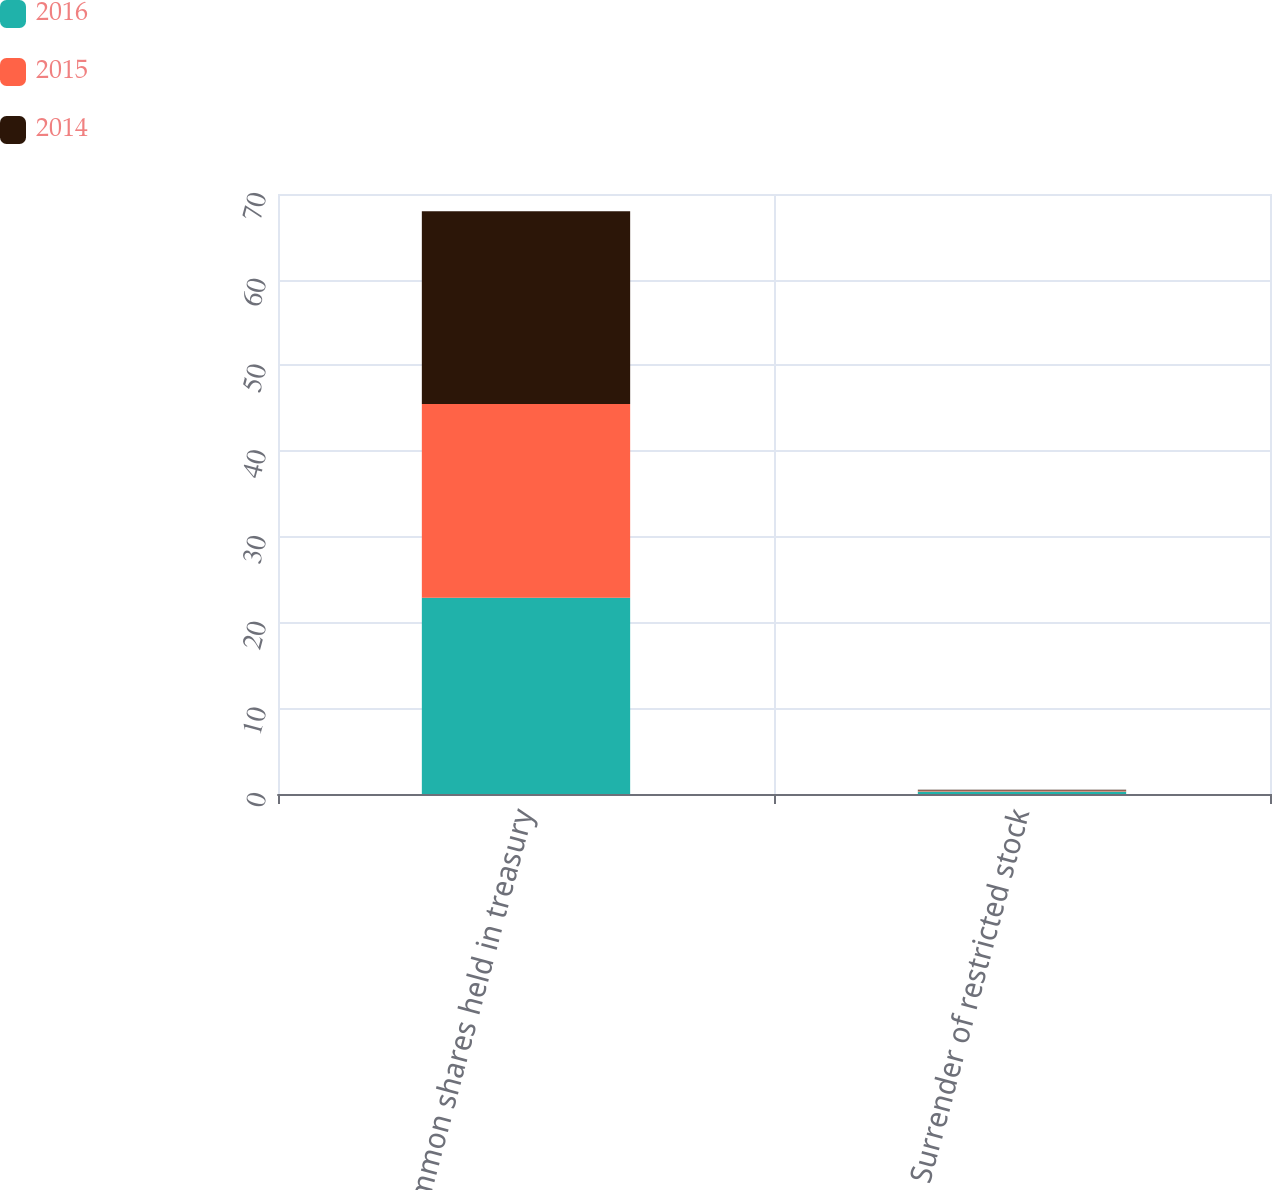Convert chart. <chart><loc_0><loc_0><loc_500><loc_500><stacked_bar_chart><ecel><fcel>Common shares held in treasury<fcel>Surrender of restricted stock<nl><fcel>2016<fcel>22.9<fcel>0.3<nl><fcel>2015<fcel>22.6<fcel>0.1<nl><fcel>2014<fcel>22.5<fcel>0.1<nl></chart> 